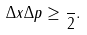<formula> <loc_0><loc_0><loc_500><loc_500>\Delta x \Delta p \geq \frac { } { 2 } .</formula> 